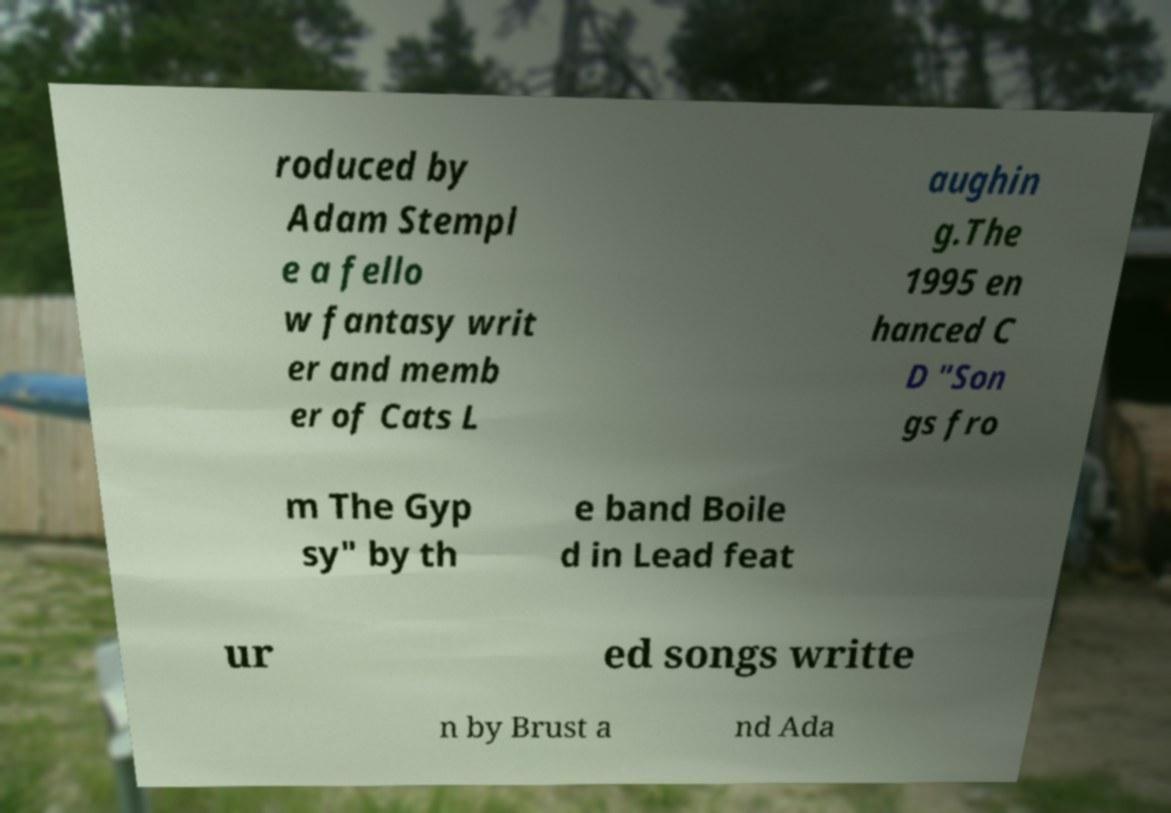What messages or text are displayed in this image? I need them in a readable, typed format. roduced by Adam Stempl e a fello w fantasy writ er and memb er of Cats L aughin g.The 1995 en hanced C D "Son gs fro m The Gyp sy" by th e band Boile d in Lead feat ur ed songs writte n by Brust a nd Ada 